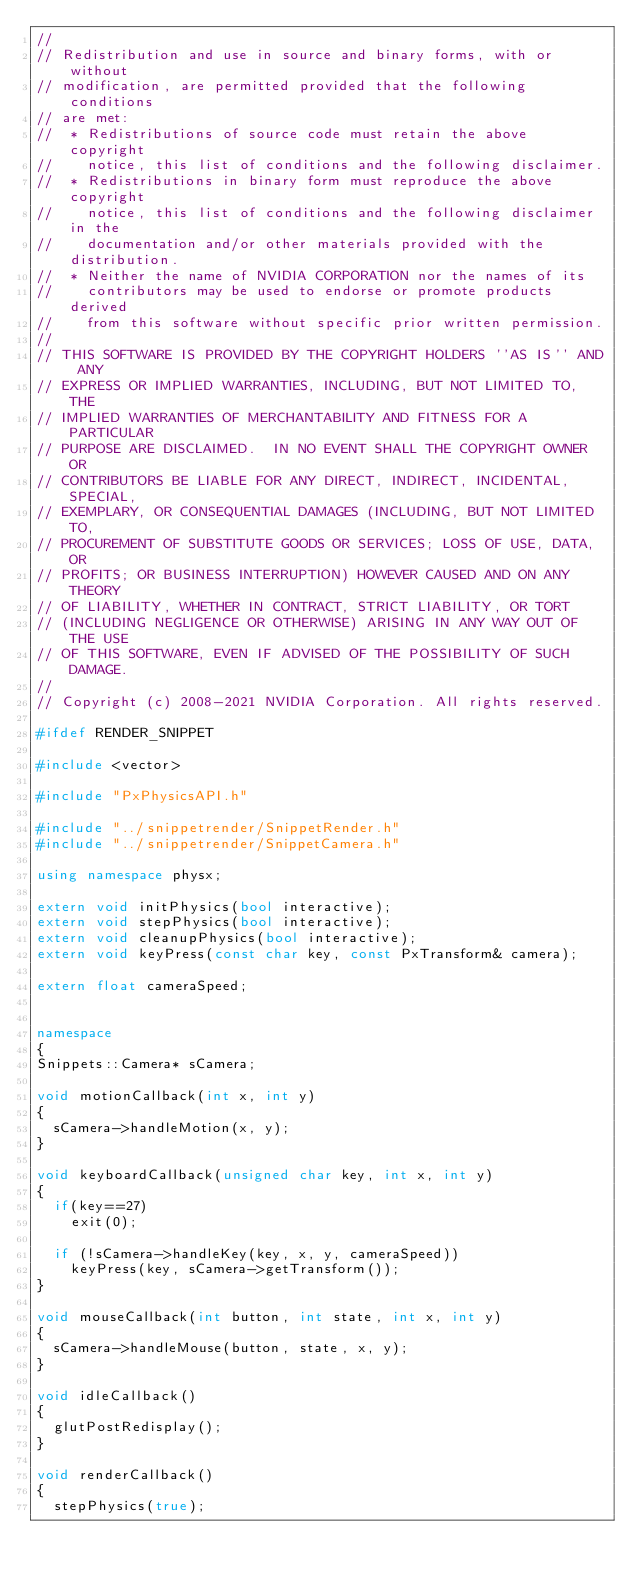<code> <loc_0><loc_0><loc_500><loc_500><_C++_>//
// Redistribution and use in source and binary forms, with or without
// modification, are permitted provided that the following conditions
// are met:
//  * Redistributions of source code must retain the above copyright
//    notice, this list of conditions and the following disclaimer.
//  * Redistributions in binary form must reproduce the above copyright
//    notice, this list of conditions and the following disclaimer in the
//    documentation and/or other materials provided with the distribution.
//  * Neither the name of NVIDIA CORPORATION nor the names of its
//    contributors may be used to endorse or promote products derived
//    from this software without specific prior written permission.
//
// THIS SOFTWARE IS PROVIDED BY THE COPYRIGHT HOLDERS ''AS IS'' AND ANY
// EXPRESS OR IMPLIED WARRANTIES, INCLUDING, BUT NOT LIMITED TO, THE
// IMPLIED WARRANTIES OF MERCHANTABILITY AND FITNESS FOR A PARTICULAR
// PURPOSE ARE DISCLAIMED.  IN NO EVENT SHALL THE COPYRIGHT OWNER OR
// CONTRIBUTORS BE LIABLE FOR ANY DIRECT, INDIRECT, INCIDENTAL, SPECIAL,
// EXEMPLARY, OR CONSEQUENTIAL DAMAGES (INCLUDING, BUT NOT LIMITED TO,
// PROCUREMENT OF SUBSTITUTE GOODS OR SERVICES; LOSS OF USE, DATA, OR
// PROFITS; OR BUSINESS INTERRUPTION) HOWEVER CAUSED AND ON ANY THEORY
// OF LIABILITY, WHETHER IN CONTRACT, STRICT LIABILITY, OR TORT
// (INCLUDING NEGLIGENCE OR OTHERWISE) ARISING IN ANY WAY OUT OF THE USE
// OF THIS SOFTWARE, EVEN IF ADVISED OF THE POSSIBILITY OF SUCH DAMAGE.
//
// Copyright (c) 2008-2021 NVIDIA Corporation. All rights reserved.

#ifdef RENDER_SNIPPET

#include <vector>

#include "PxPhysicsAPI.h"

#include "../snippetrender/SnippetRender.h"
#include "../snippetrender/SnippetCamera.h"

using namespace physx;

extern void initPhysics(bool interactive);
extern void stepPhysics(bool interactive);	
extern void cleanupPhysics(bool interactive);
extern void keyPress(const char key, const PxTransform& camera);

extern float cameraSpeed;


namespace
{
Snippets::Camera*	sCamera;

void motionCallback(int x, int y)
{
	sCamera->handleMotion(x, y);
}

void keyboardCallback(unsigned char key, int x, int y)
{
	if(key==27)
		exit(0);

	if (!sCamera->handleKey(key, x, y, cameraSpeed))
		keyPress(key, sCamera->getTransform());
}

void mouseCallback(int button, int state, int x, int y)
{
	sCamera->handleMouse(button, state, x, y);
}

void idleCallback()
{
	glutPostRedisplay();
}

void renderCallback()
{
	stepPhysics(true);
</code> 